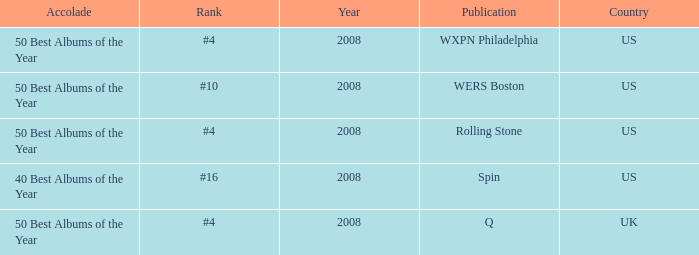Which year's rank was #4 when the country was the US? 2008, 2008. 